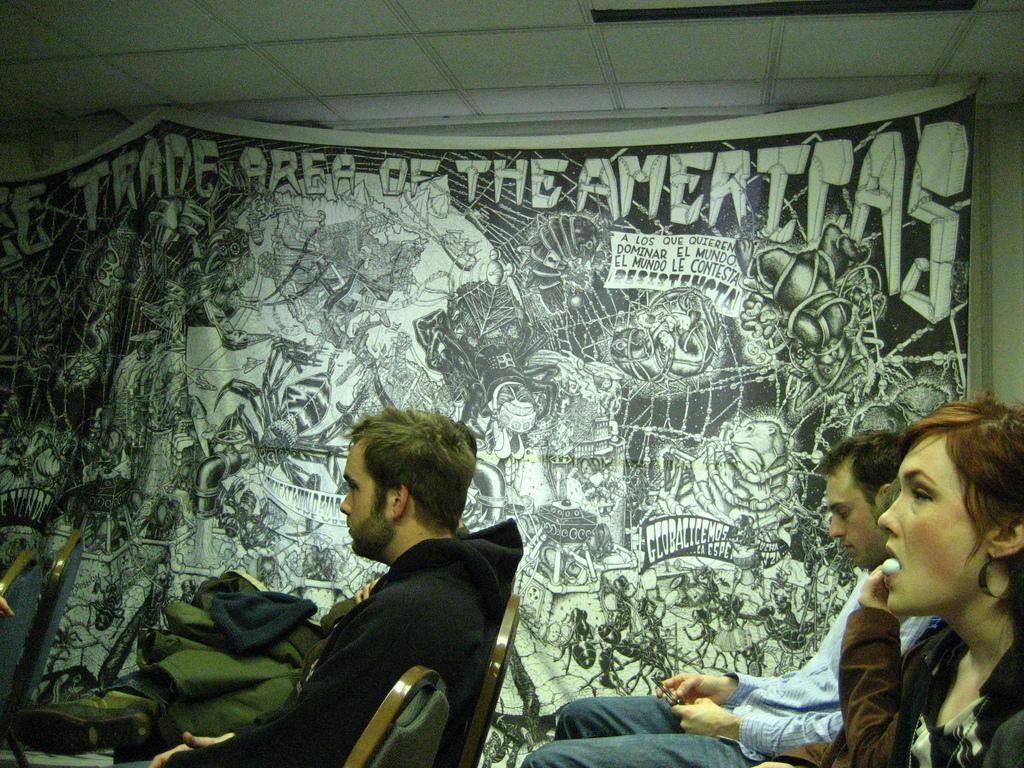Please provide a concise description of this image. In this image we can see few people sitting on the chairs and there is a banner with images and text hanged to the wall. 